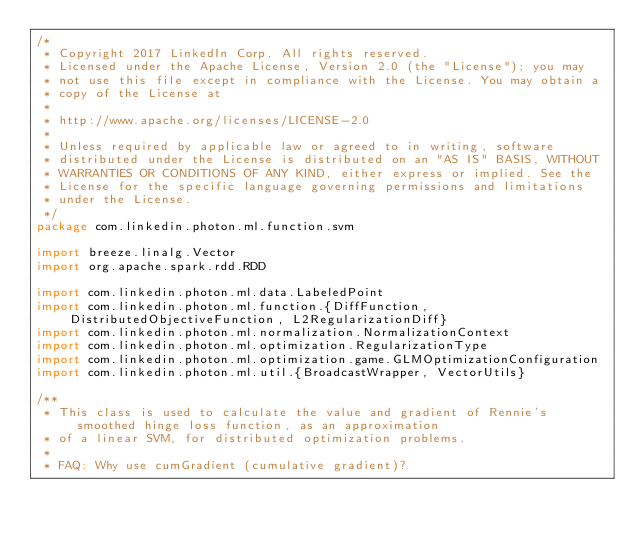Convert code to text. <code><loc_0><loc_0><loc_500><loc_500><_Scala_>/*
 * Copyright 2017 LinkedIn Corp. All rights reserved.
 * Licensed under the Apache License, Version 2.0 (the "License"); you may
 * not use this file except in compliance with the License. You may obtain a
 * copy of the License at
 *
 * http://www.apache.org/licenses/LICENSE-2.0
 *
 * Unless required by applicable law or agreed to in writing, software
 * distributed under the License is distributed on an "AS IS" BASIS, WITHOUT
 * WARRANTIES OR CONDITIONS OF ANY KIND, either express or implied. See the
 * License for the specific language governing permissions and limitations
 * under the License.
 */
package com.linkedin.photon.ml.function.svm

import breeze.linalg.Vector
import org.apache.spark.rdd.RDD

import com.linkedin.photon.ml.data.LabeledPoint
import com.linkedin.photon.ml.function.{DiffFunction, DistributedObjectiveFunction, L2RegularizationDiff}
import com.linkedin.photon.ml.normalization.NormalizationContext
import com.linkedin.photon.ml.optimization.RegularizationType
import com.linkedin.photon.ml.optimization.game.GLMOptimizationConfiguration
import com.linkedin.photon.ml.util.{BroadcastWrapper, VectorUtils}

/**
 * This class is used to calculate the value and gradient of Rennie's smoothed hinge loss function, as an approximation
 * of a linear SVM, for distributed optimization problems.
 *
 * FAQ: Why use cumGradient (cumulative gradient)?</code> 